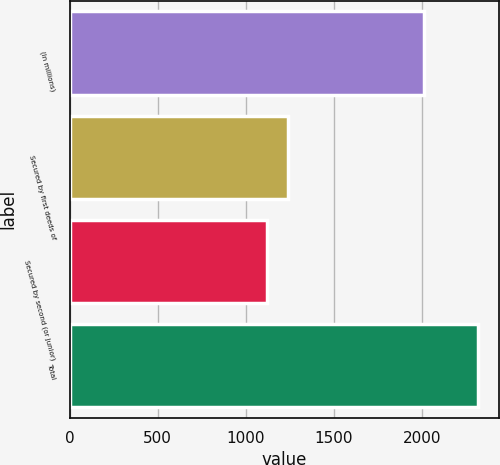Convert chart. <chart><loc_0><loc_0><loc_500><loc_500><bar_chart><fcel>(In millions)<fcel>Secured by first deeds of<fcel>Secured by second (or junior)<fcel>Total<nl><fcel>2014<fcel>1240.1<fcel>1120<fcel>2321<nl></chart> 